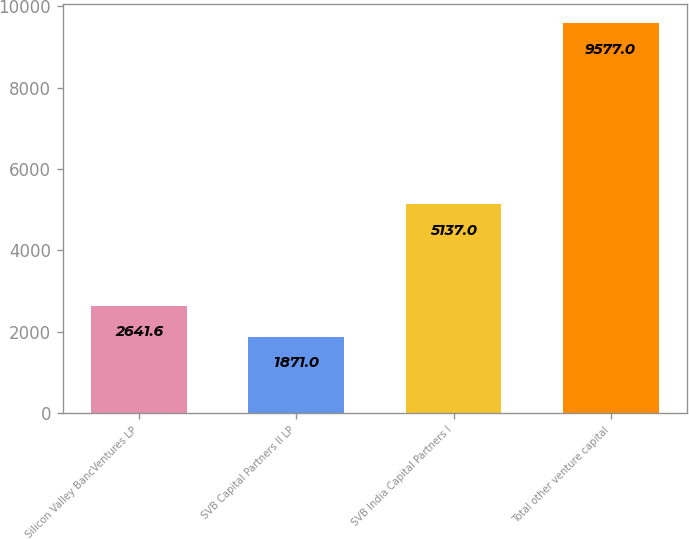<chart> <loc_0><loc_0><loc_500><loc_500><bar_chart><fcel>Silicon Valley BancVentures LP<fcel>SVB Capital Partners II LP<fcel>SVB India Capital Partners I<fcel>Total other venture capital<nl><fcel>2641.6<fcel>1871<fcel>5137<fcel>9577<nl></chart> 